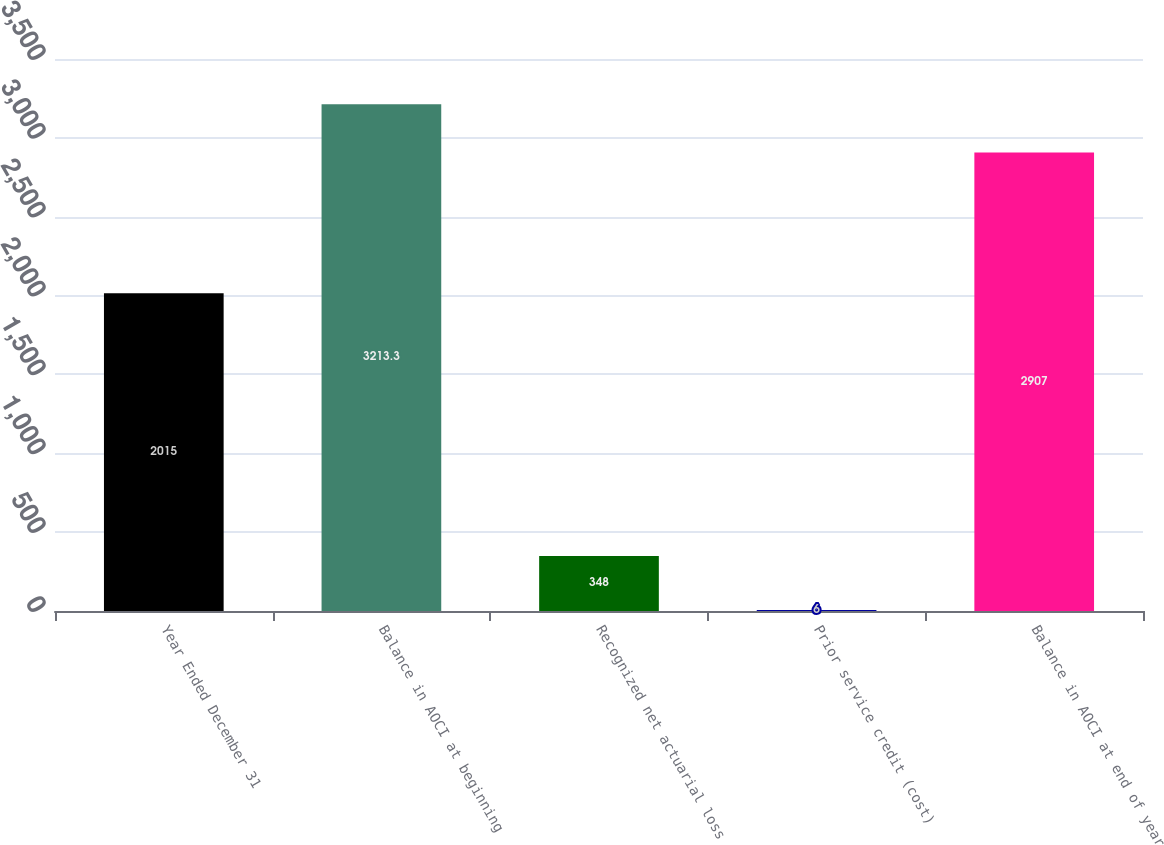Convert chart to OTSL. <chart><loc_0><loc_0><loc_500><loc_500><bar_chart><fcel>Year Ended December 31<fcel>Balance in AOCI at beginning<fcel>Recognized net actuarial loss<fcel>Prior service credit (cost)<fcel>Balance in AOCI at end of year<nl><fcel>2015<fcel>3213.3<fcel>348<fcel>6<fcel>2907<nl></chart> 